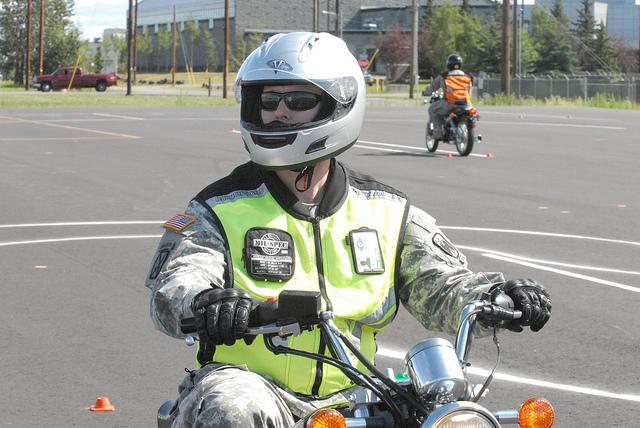What part of the rider's face is visible with the helmet on?
Keep it brief. Eyes and nose. What color is the truck in the background?
Be succinct. Red. Where is this?
Be succinct. Parking lot. 